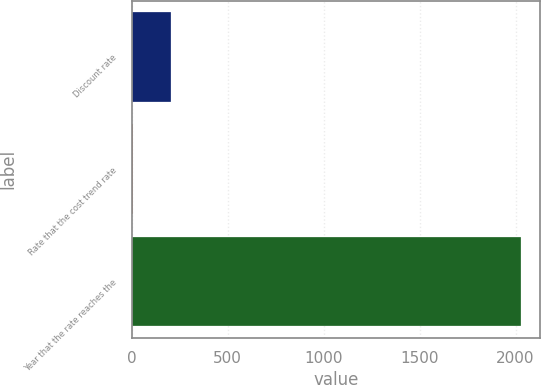Convert chart. <chart><loc_0><loc_0><loc_500><loc_500><bar_chart><fcel>Discount rate<fcel>Rate that the cost trend rate<fcel>Year that the rate reaches the<nl><fcel>207.44<fcel>5.15<fcel>2028<nl></chart> 